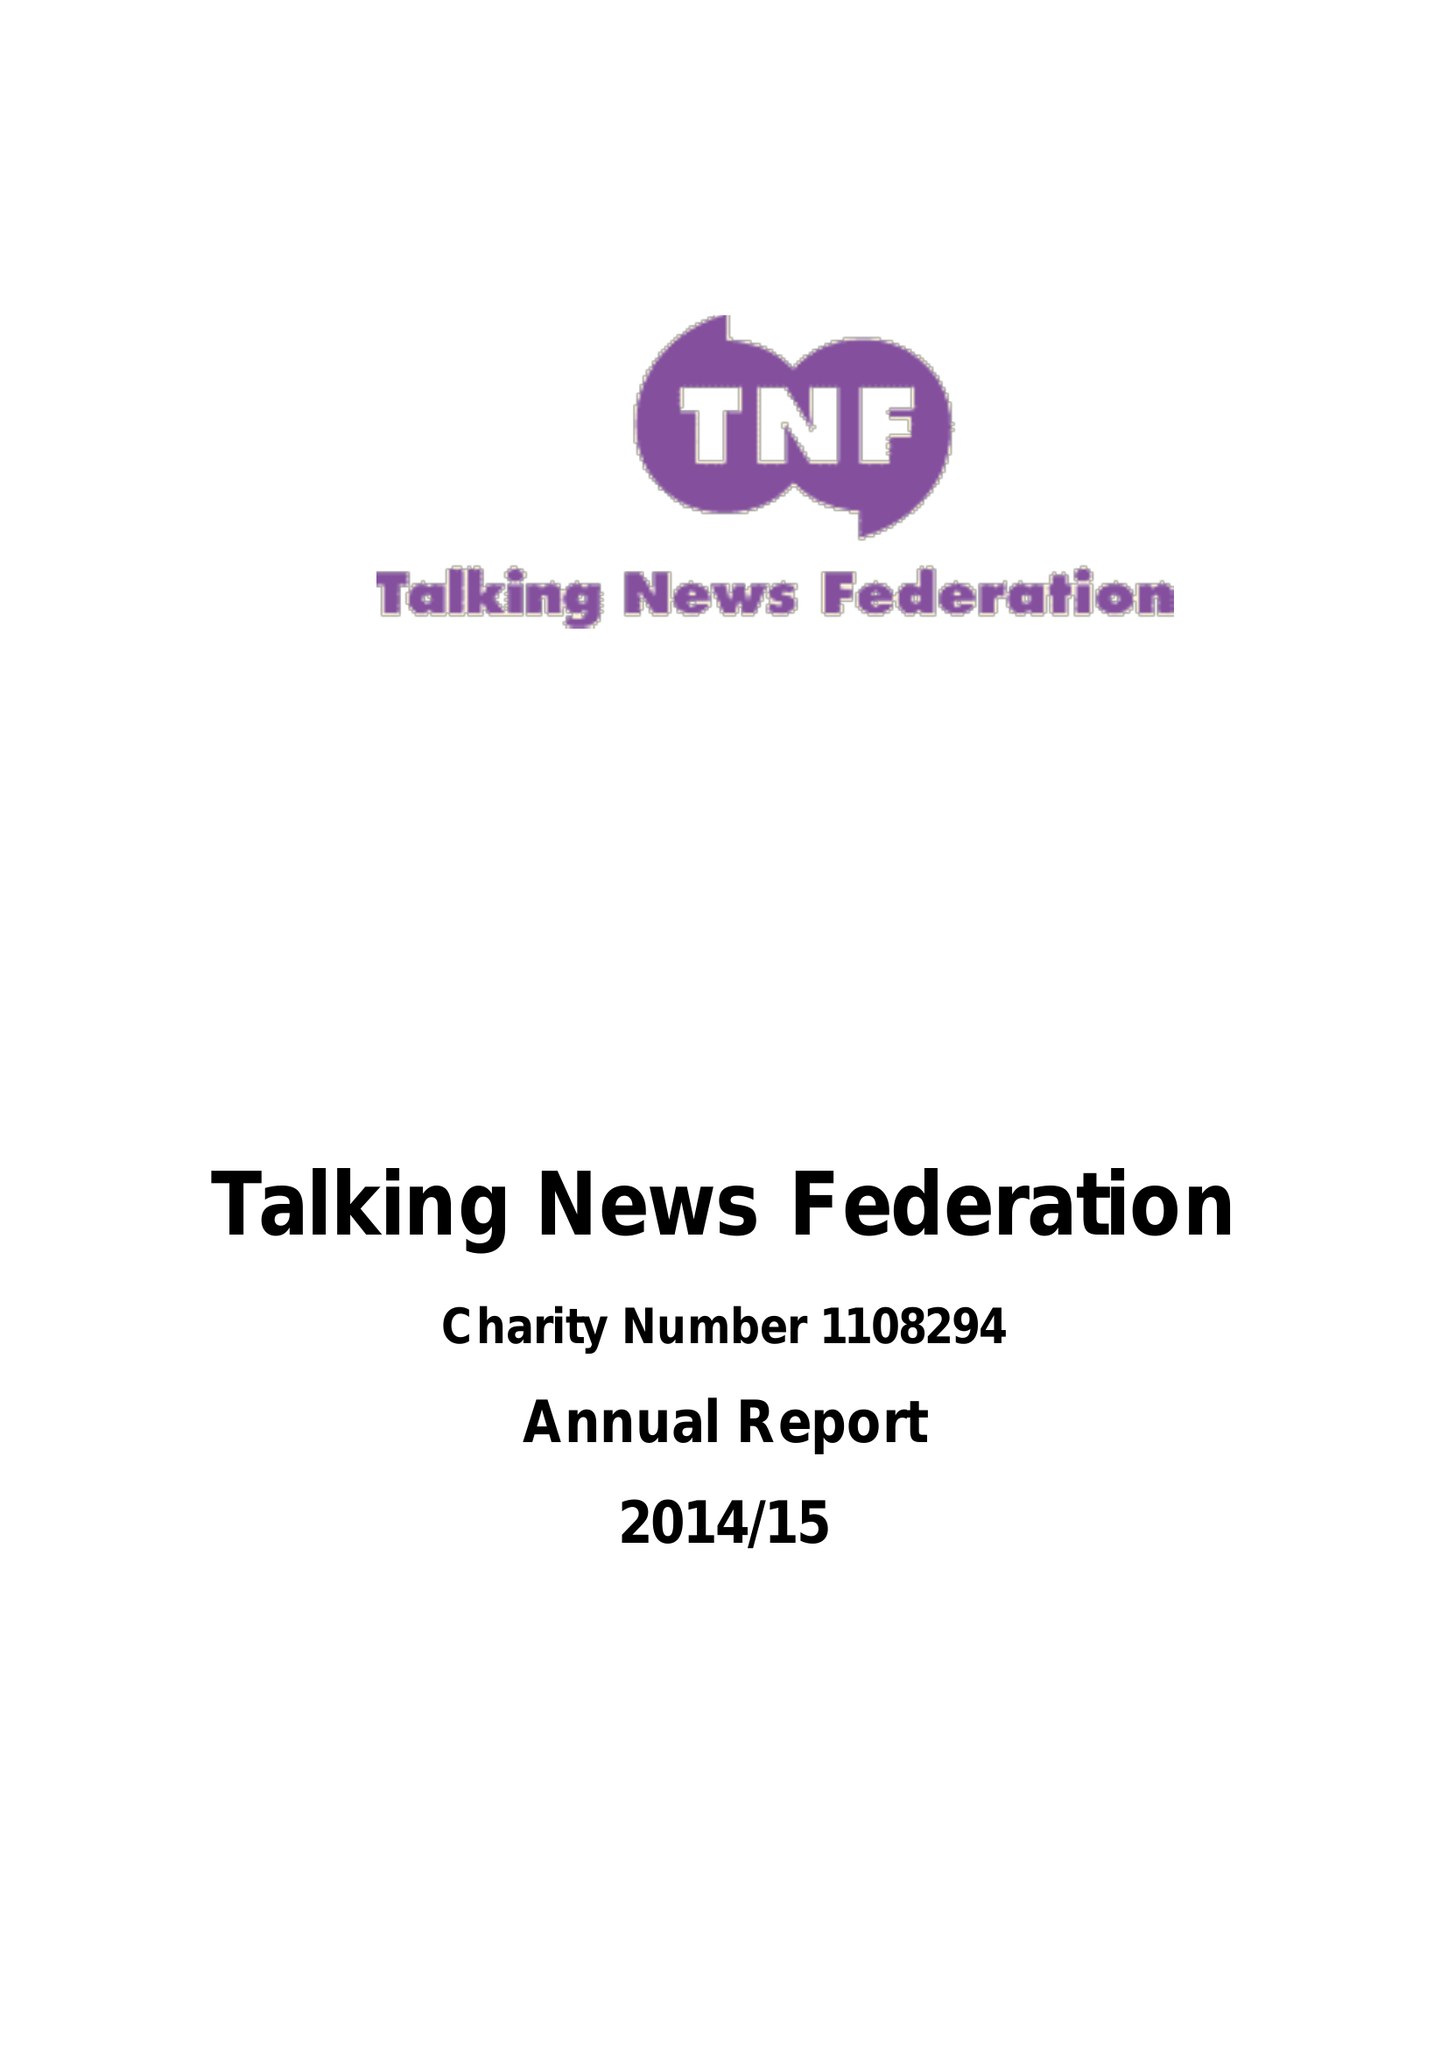What is the value for the charity_name?
Answer the question using a single word or phrase. Talking News Federation 